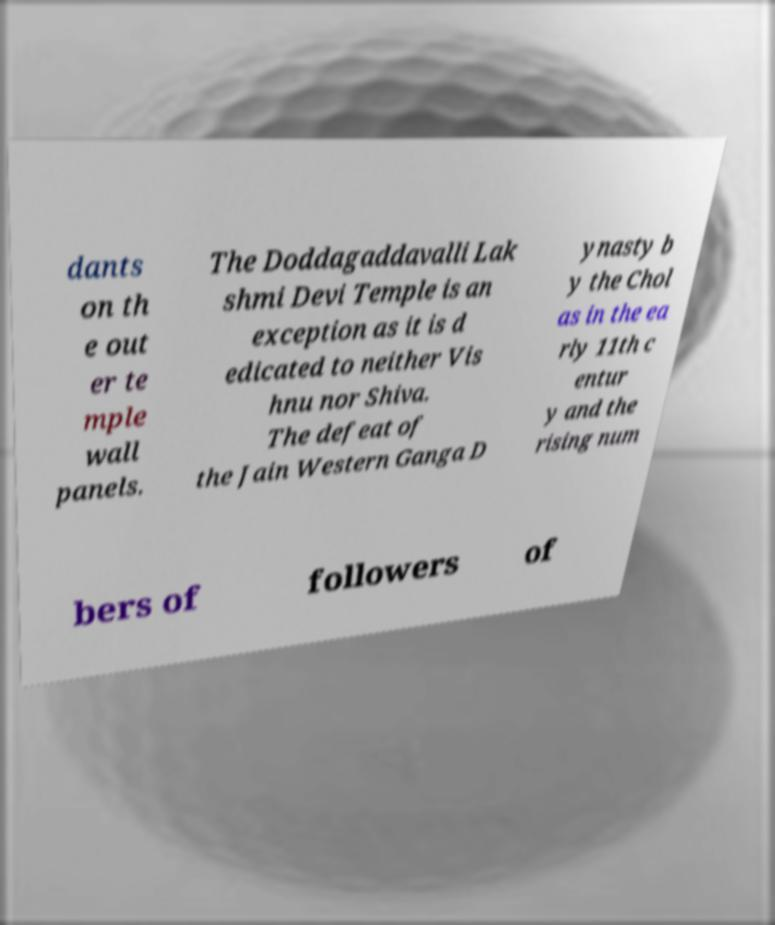Can you read and provide the text displayed in the image?This photo seems to have some interesting text. Can you extract and type it out for me? dants on th e out er te mple wall panels. The Doddagaddavalli Lak shmi Devi Temple is an exception as it is d edicated to neither Vis hnu nor Shiva. The defeat of the Jain Western Ganga D ynasty b y the Chol as in the ea rly 11th c entur y and the rising num bers of followers of 